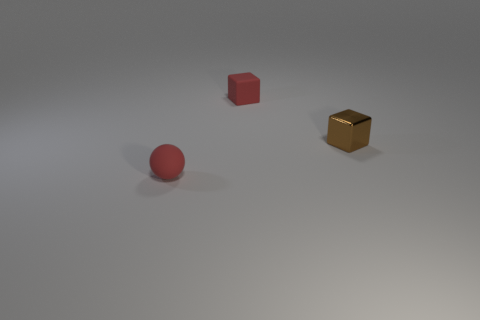What shape is the small matte object that is the same color as the small rubber sphere?
Offer a very short reply. Cube. Do the tiny metal block and the matte block have the same color?
Your answer should be very brief. No. Are there more blocks left of the metallic thing than large green shiny cylinders?
Give a very brief answer. Yes. What number of other things are the same material as the sphere?
Provide a short and direct response. 1. How many big things are either gray spheres or brown blocks?
Provide a succinct answer. 0. Is the red sphere made of the same material as the brown object?
Provide a succinct answer. No. How many small red rubber things are in front of the matte object that is right of the sphere?
Provide a succinct answer. 1. Are there any red matte things of the same shape as the small brown metallic object?
Your answer should be very brief. Yes. There is a small red thing that is behind the brown block; is it the same shape as the thing right of the red matte cube?
Give a very brief answer. Yes. There is a thing that is both behind the small red ball and left of the tiny brown thing; what is its shape?
Make the answer very short. Cube. 